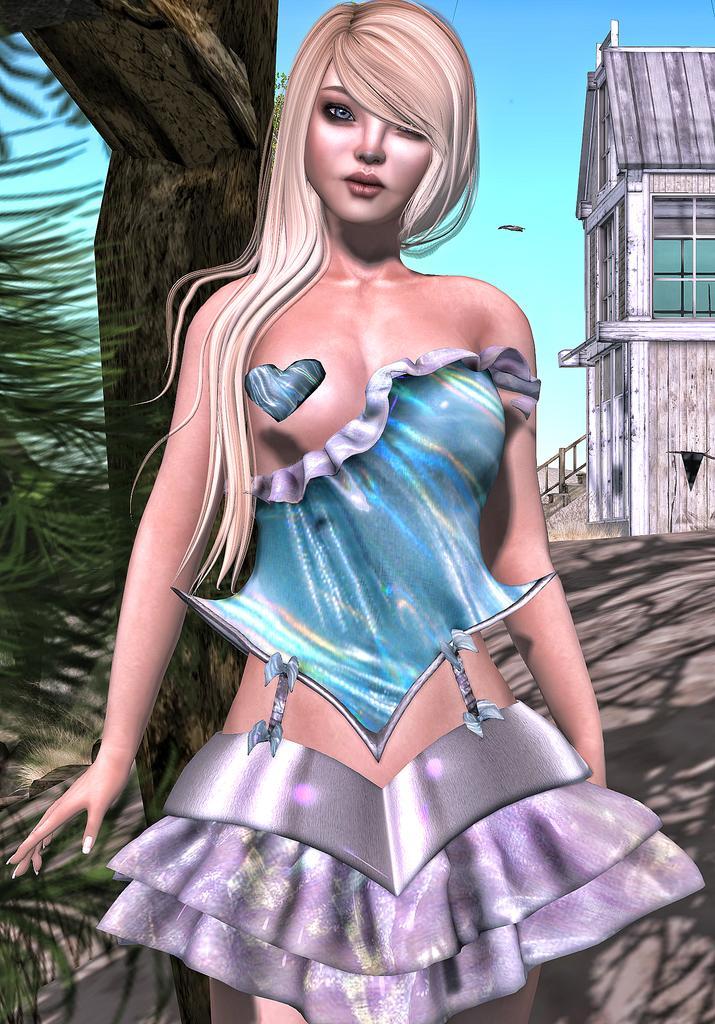Please provide a concise description of this image. This is an animated picture. In the center of the picture there is a woman. On the right there are plants, grass and a tree. On the right there is a building. In the background it is sky. 